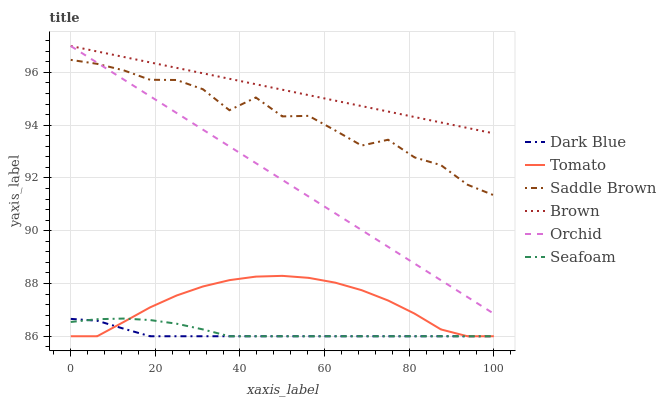Does Dark Blue have the minimum area under the curve?
Answer yes or no. Yes. Does Brown have the maximum area under the curve?
Answer yes or no. Yes. Does Seafoam have the minimum area under the curve?
Answer yes or no. No. Does Seafoam have the maximum area under the curve?
Answer yes or no. No. Is Brown the smoothest?
Answer yes or no. Yes. Is Saddle Brown the roughest?
Answer yes or no. Yes. Is Seafoam the smoothest?
Answer yes or no. No. Is Seafoam the roughest?
Answer yes or no. No. Does Tomato have the lowest value?
Answer yes or no. Yes. Does Brown have the lowest value?
Answer yes or no. No. Does Orchid have the highest value?
Answer yes or no. Yes. Does Seafoam have the highest value?
Answer yes or no. No. Is Tomato less than Saddle Brown?
Answer yes or no. Yes. Is Brown greater than Dark Blue?
Answer yes or no. Yes. Does Seafoam intersect Tomato?
Answer yes or no. Yes. Is Seafoam less than Tomato?
Answer yes or no. No. Is Seafoam greater than Tomato?
Answer yes or no. No. Does Tomato intersect Saddle Brown?
Answer yes or no. No. 